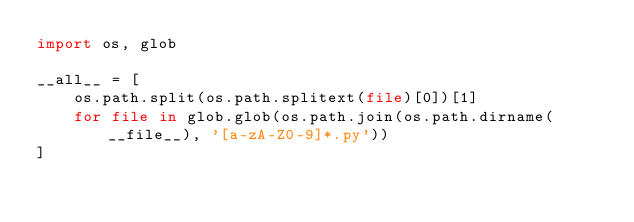Convert code to text. <code><loc_0><loc_0><loc_500><loc_500><_Python_>import os, glob

__all__ = [
    os.path.split(os.path.splitext(file)[0])[1]
    for file in glob.glob(os.path.join(os.path.dirname(__file__), '[a-zA-Z0-9]*.py'))
]</code> 